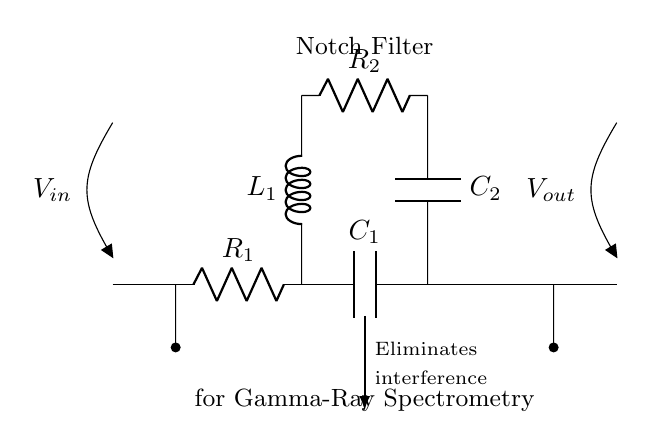What is the input voltage of this circuit? The input voltage is represented by V_in, which is the potential difference applied at the input terminal of the circuit.
Answer: V_in What type of components are used in this notch filter? The notch filter consists of resistors, capacitors, and an inductor. Specifically, R1, R2, C1, C2, and L1 form the overall structure of the filter.
Answer: Resistors, capacitors, inductor What does the notch filter eliminate? The diagram indicates that it eliminates interference, which is a key aspect of the filter's purpose in gamma-ray spectrometry applications.
Answer: Interference What is the output voltage of this circuit? The output voltage is denoted as V_out, which represents the potential difference measured across the output terminal of the circuit.
Answer: V_out Which component connects directly to the input? The input connects to the first resistor, R1, which determines the initial behavior of the circuit in response to the input signal.
Answer: R1 Why are there two capacitors in this circuit? The two capacitors, C1 and C2, serve distinct roles; C1 is part of the high-pass section, while C2 is involved in the feedback loop to create resonance with the inductor and assist in interference elimination at a specific frequency.
Answer: Resonance and interference elimination What type of filter is represented in this circuit? This circuit is a notch filter, which is specifically designed to attenuate signals at a certain frequency while passing other frequencies, crucial for gamma-ray spectrometry.
Answer: Notch filter 